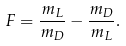<formula> <loc_0><loc_0><loc_500><loc_500>F = \frac { m _ { L } } { m _ { D } } - \frac { m _ { D } } { m _ { L } } .</formula> 